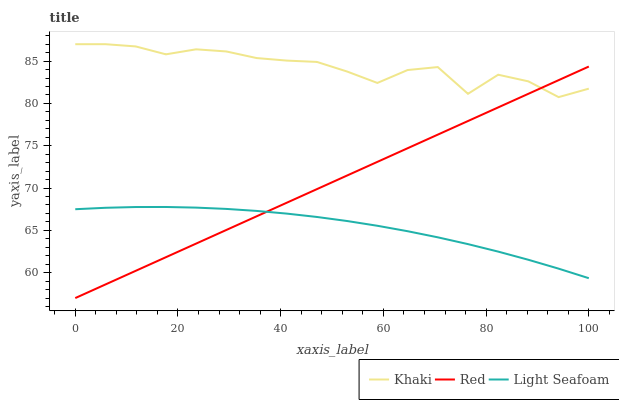Does Light Seafoam have the minimum area under the curve?
Answer yes or no. Yes. Does Khaki have the maximum area under the curve?
Answer yes or no. Yes. Does Red have the minimum area under the curve?
Answer yes or no. No. Does Red have the maximum area under the curve?
Answer yes or no. No. Is Red the smoothest?
Answer yes or no. Yes. Is Khaki the roughest?
Answer yes or no. Yes. Is Khaki the smoothest?
Answer yes or no. No. Is Red the roughest?
Answer yes or no. No. Does Red have the lowest value?
Answer yes or no. Yes. Does Khaki have the lowest value?
Answer yes or no. No. Does Khaki have the highest value?
Answer yes or no. Yes. Does Red have the highest value?
Answer yes or no. No. Is Light Seafoam less than Khaki?
Answer yes or no. Yes. Is Khaki greater than Light Seafoam?
Answer yes or no. Yes. Does Khaki intersect Red?
Answer yes or no. Yes. Is Khaki less than Red?
Answer yes or no. No. Is Khaki greater than Red?
Answer yes or no. No. Does Light Seafoam intersect Khaki?
Answer yes or no. No. 